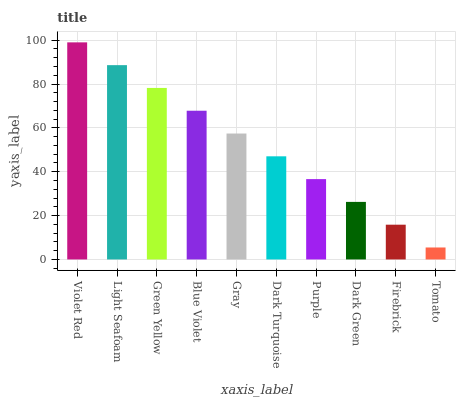Is Tomato the minimum?
Answer yes or no. Yes. Is Violet Red the maximum?
Answer yes or no. Yes. Is Light Seafoam the minimum?
Answer yes or no. No. Is Light Seafoam the maximum?
Answer yes or no. No. Is Violet Red greater than Light Seafoam?
Answer yes or no. Yes. Is Light Seafoam less than Violet Red?
Answer yes or no. Yes. Is Light Seafoam greater than Violet Red?
Answer yes or no. No. Is Violet Red less than Light Seafoam?
Answer yes or no. No. Is Gray the high median?
Answer yes or no. Yes. Is Dark Turquoise the low median?
Answer yes or no. Yes. Is Light Seafoam the high median?
Answer yes or no. No. Is Gray the low median?
Answer yes or no. No. 